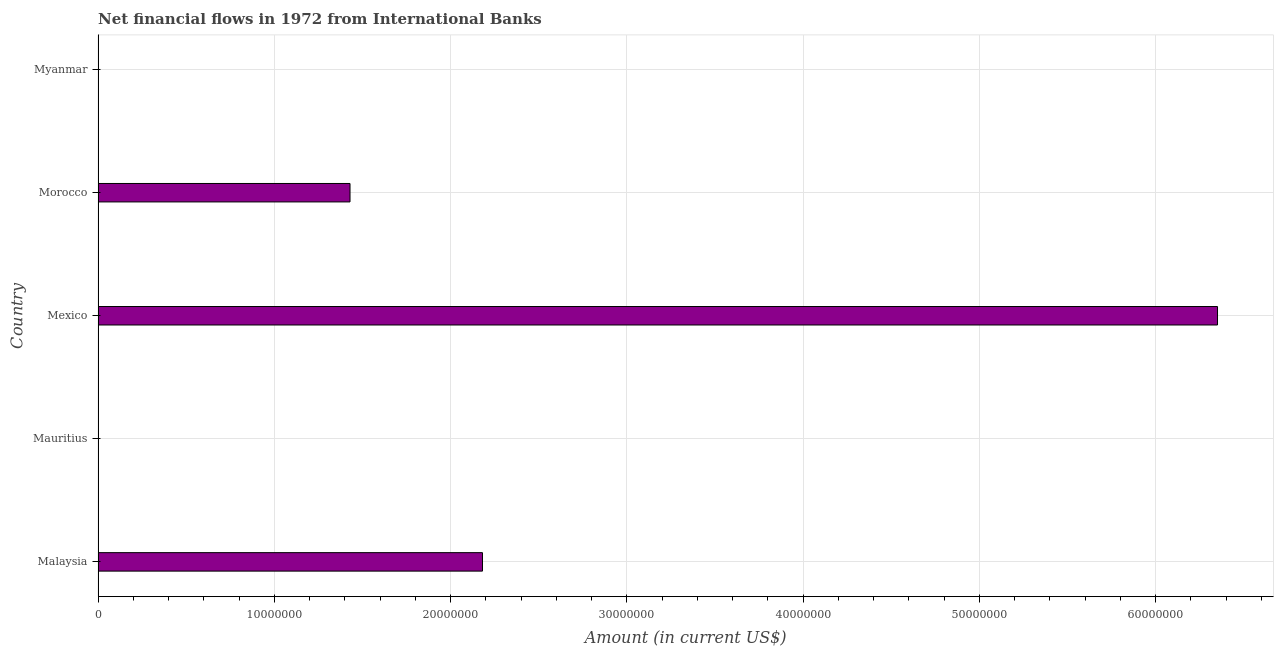Does the graph contain grids?
Provide a succinct answer. Yes. What is the title of the graph?
Keep it short and to the point. Net financial flows in 1972 from International Banks. What is the label or title of the Y-axis?
Ensure brevity in your answer.  Country. Across all countries, what is the maximum net financial flows from ibrd?
Your answer should be very brief. 6.35e+07. What is the sum of the net financial flows from ibrd?
Ensure brevity in your answer.  9.96e+07. What is the difference between the net financial flows from ibrd in Mexico and Morocco?
Your response must be concise. 4.92e+07. What is the average net financial flows from ibrd per country?
Offer a terse response. 1.99e+07. What is the median net financial flows from ibrd?
Your answer should be compact. 1.43e+07. What is the ratio of the net financial flows from ibrd in Malaysia to that in Morocco?
Provide a short and direct response. 1.53. Is the net financial flows from ibrd in Malaysia less than that in Morocco?
Your response must be concise. No. Is the difference between the net financial flows from ibrd in Malaysia and Mexico greater than the difference between any two countries?
Your answer should be very brief. No. What is the difference between the highest and the second highest net financial flows from ibrd?
Offer a very short reply. 4.17e+07. What is the difference between the highest and the lowest net financial flows from ibrd?
Provide a succinct answer. 6.35e+07. In how many countries, is the net financial flows from ibrd greater than the average net financial flows from ibrd taken over all countries?
Provide a succinct answer. 2. How many bars are there?
Provide a short and direct response. 3. Are all the bars in the graph horizontal?
Provide a succinct answer. Yes. Are the values on the major ticks of X-axis written in scientific E-notation?
Give a very brief answer. No. What is the Amount (in current US$) in Malaysia?
Keep it short and to the point. 2.18e+07. What is the Amount (in current US$) of Mexico?
Provide a short and direct response. 6.35e+07. What is the Amount (in current US$) in Morocco?
Make the answer very short. 1.43e+07. What is the difference between the Amount (in current US$) in Malaysia and Mexico?
Your answer should be compact. -4.17e+07. What is the difference between the Amount (in current US$) in Malaysia and Morocco?
Provide a succinct answer. 7.52e+06. What is the difference between the Amount (in current US$) in Mexico and Morocco?
Keep it short and to the point. 4.92e+07. What is the ratio of the Amount (in current US$) in Malaysia to that in Mexico?
Keep it short and to the point. 0.34. What is the ratio of the Amount (in current US$) in Malaysia to that in Morocco?
Keep it short and to the point. 1.53. What is the ratio of the Amount (in current US$) in Mexico to that in Morocco?
Offer a very short reply. 4.44. 